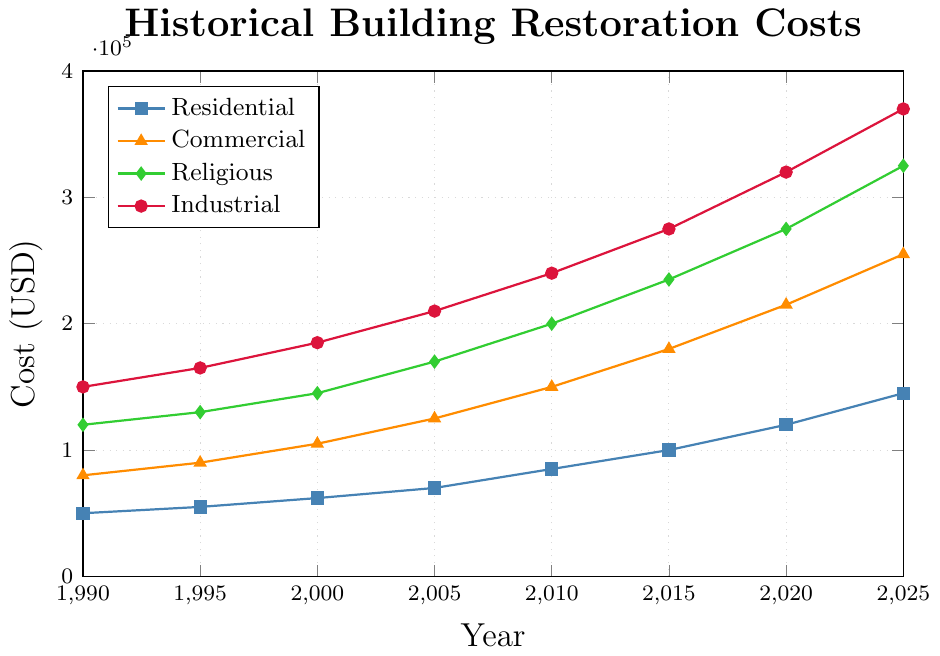What is the total restoration cost for Religious structures in 2025? To find the total restoration cost for Religious structures in 2025, look for the value corresponding to Religious structures and the year 2025.
Answer: $325,000 Which type of structure had the highest restoration cost in 2010? Compare the costs of all structures in 2010. The numbers are $85,000 (Residential), $150,000 (Commercial), $200,000 (Religious), and $240,000 (Industrial). The highest value is $240,000 for Industrial.
Answer: Industrial What is the increase in restoration costs for Residential buildings from 1990 to 2025? Subtract the 1990 cost from the 2025 cost for Residential buildings: $145,000 - $50,000.
Answer: $95,000 How does the restoration cost for Commercial structures in 2005 compare to Industrial structures in the same year? Compare the two values: $125,000 (Commercial) vs. $210,000 (Industrial). Industrial structures have a higher cost.
Answer: Industrial is higher Which structure type experienced the largest increase in restoration costs between 1990 and 2025? Calculate the increase for each type: Residential ($145,000 - $50,000 = $95,000), Commercial ($255,000 - $80,000 = $175,000), Religious ($325,000 - $120,000 = $205,000), Industrial ($370,000 - $150,000 = $220,000). The largest increase is for Industrial structures.
Answer: Industrial What is the average restoration cost for Commercial structures over the years shown? Add up the costs for Commercial structures across all years and divide by the number of data points (8). ($80,000 + $90,000 + $105,000 + $125,000 + $150,000 + $180,000 + $215,000 + $255,000) / 8 = $150,000.
Answer: $150,000 What is the percentage increase in restoration costs for Industrial buildings from 2000 to 2020? Calculate the increase first: $320,000 - $185,000 = $135,000. Then, the percentage increase is ($135,000 / $185,000) * 100 ≈ 72.97%.
Answer: 72.97% In what year do Commercial structures surpass Residential ones in terms of restoration costs? Examine each year and compare costs: In 1990 Commercial ($80,000) > Residential ($50,000).
Answer: 1990 How does the restoration cost trend for Residential buildings from 1990 to 2025 appear visually on the chart? From 1990 to 2025, the restoration costs of Residential buildings show a steady increase, as indicated by a consistently upward-sloping line on the chart.
Answer: Steady increase Which type of structure shows the most consistent increase in restoration costs over the given period? By visually examining each line, Residential, Commercial, and Religious structures all show consistent increases, but the Industrial structures show the most pronounced and relatively consistent increase over the years.
Answer: Industrial 